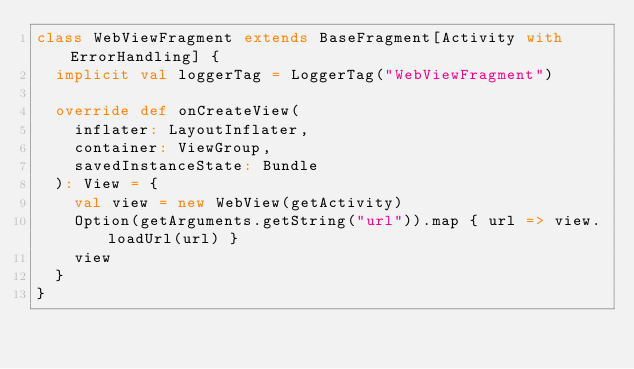Convert code to text. <code><loc_0><loc_0><loc_500><loc_500><_Scala_>class WebViewFragment extends BaseFragment[Activity with ErrorHandling] {
  implicit val loggerTag = LoggerTag("WebViewFragment")

  override def onCreateView(
    inflater: LayoutInflater,
    container: ViewGroup,
    savedInstanceState: Bundle
  ): View = {
    val view = new WebView(getActivity)
    Option(getArguments.getString("url")).map { url => view.loadUrl(url) }
    view
  }
}
</code> 